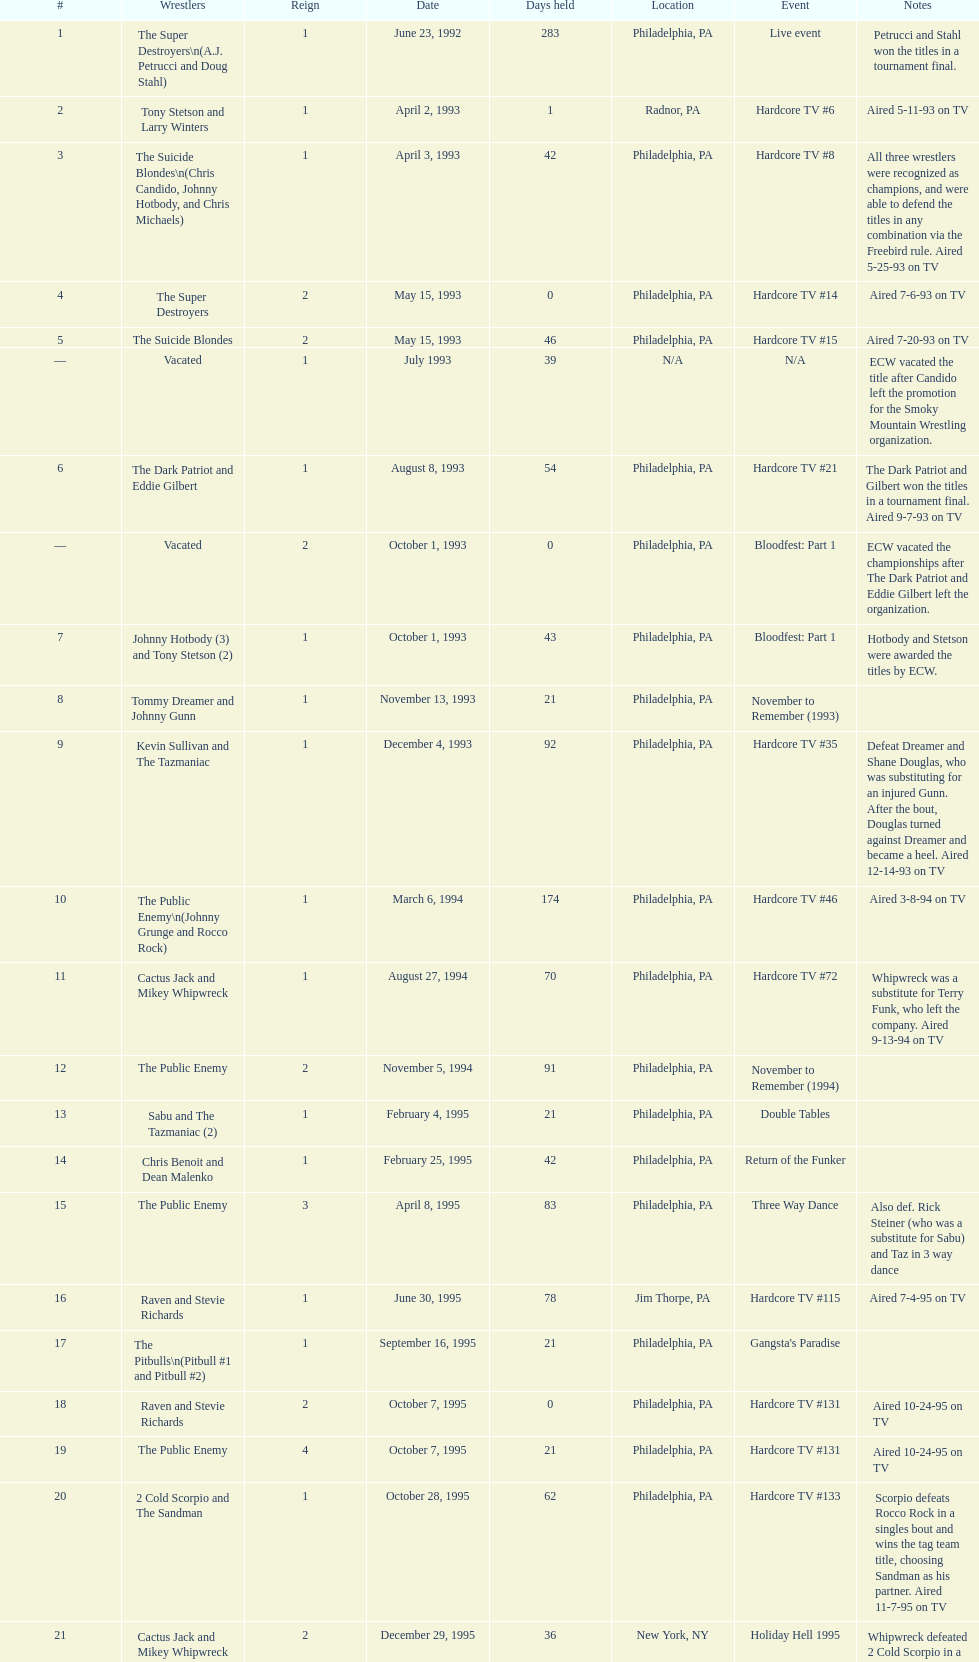What is the subsequent event following hardcore tv #15? Hardcore TV #21. 